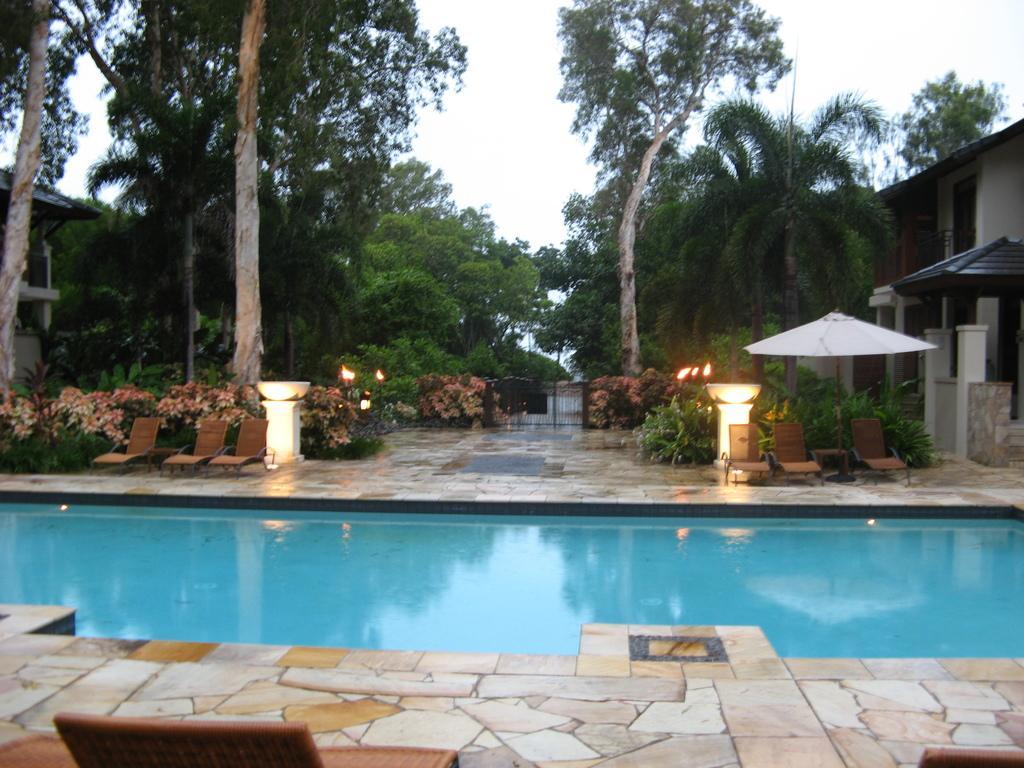Describe this image in one or two sentences. In this picture there is water at the bottom side of the image and there are chairs, trees, and houses in the background area of the image and there is an umbrella on the right side of the image. 